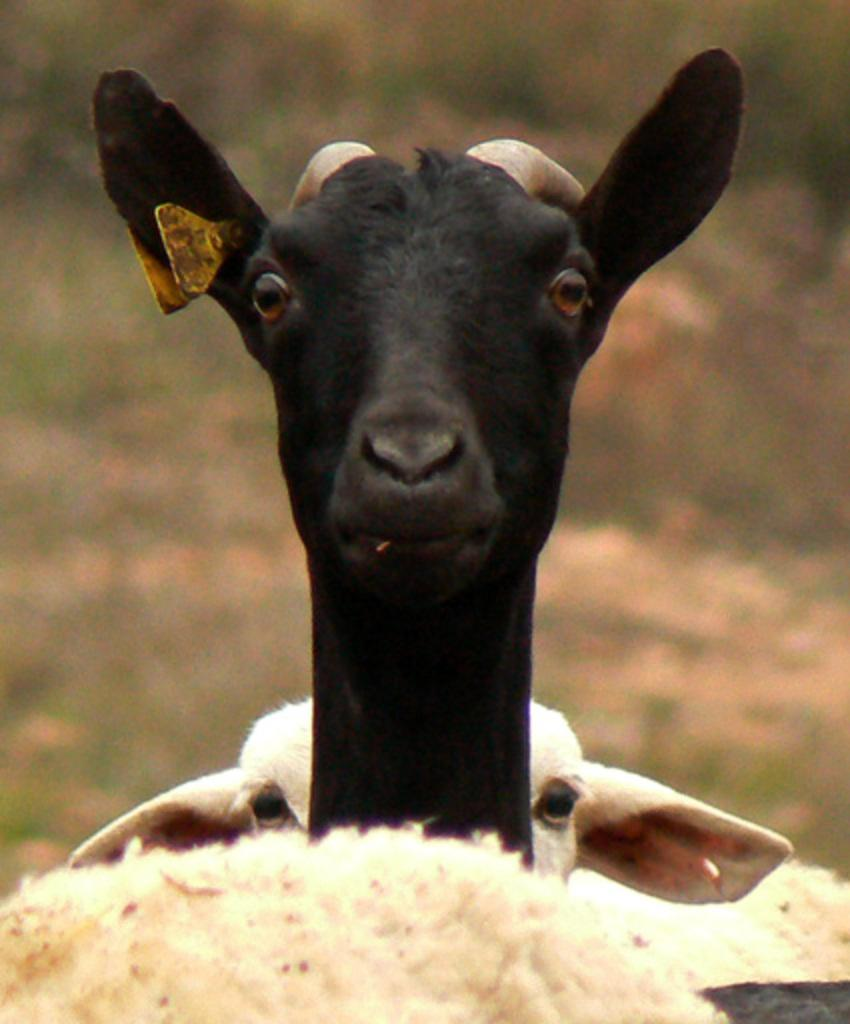What types of living organisms can be seen in the image? There are animals in the image. Can you describe the background of the image? The background of the image is blurred. What type of poison is being used by the tiger in the image? There is no tiger present in the image, and therefore no poison can be observed. How does the lift function in the image? There is no lift present in the image. 